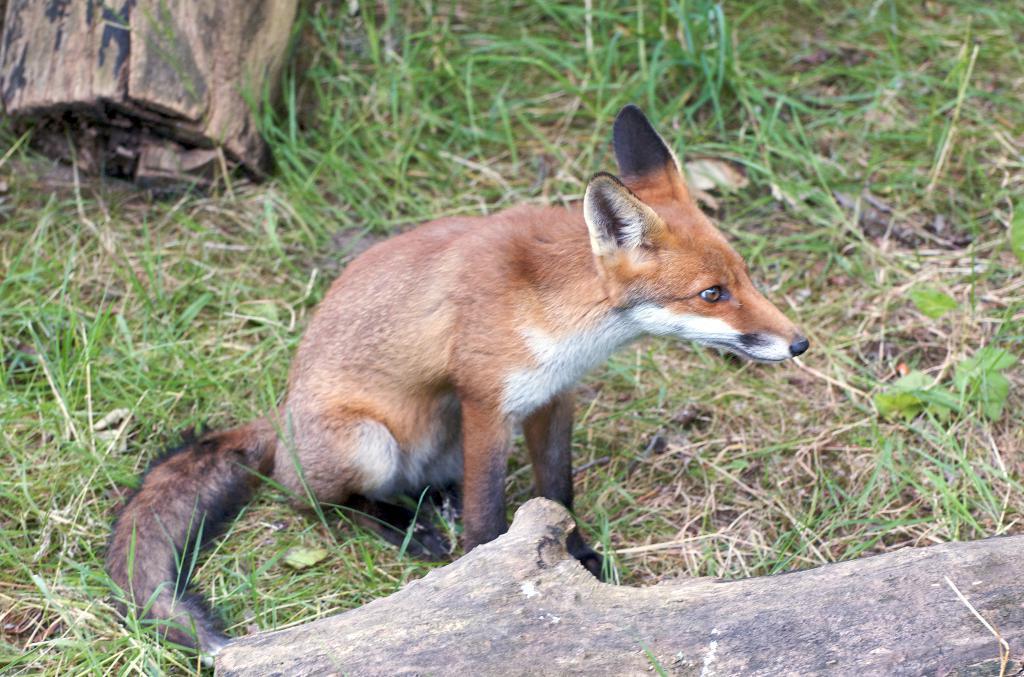Can you describe this image briefly? In this picture we can see an animal and wooden logs on the ground and in the background we can see the grass. 